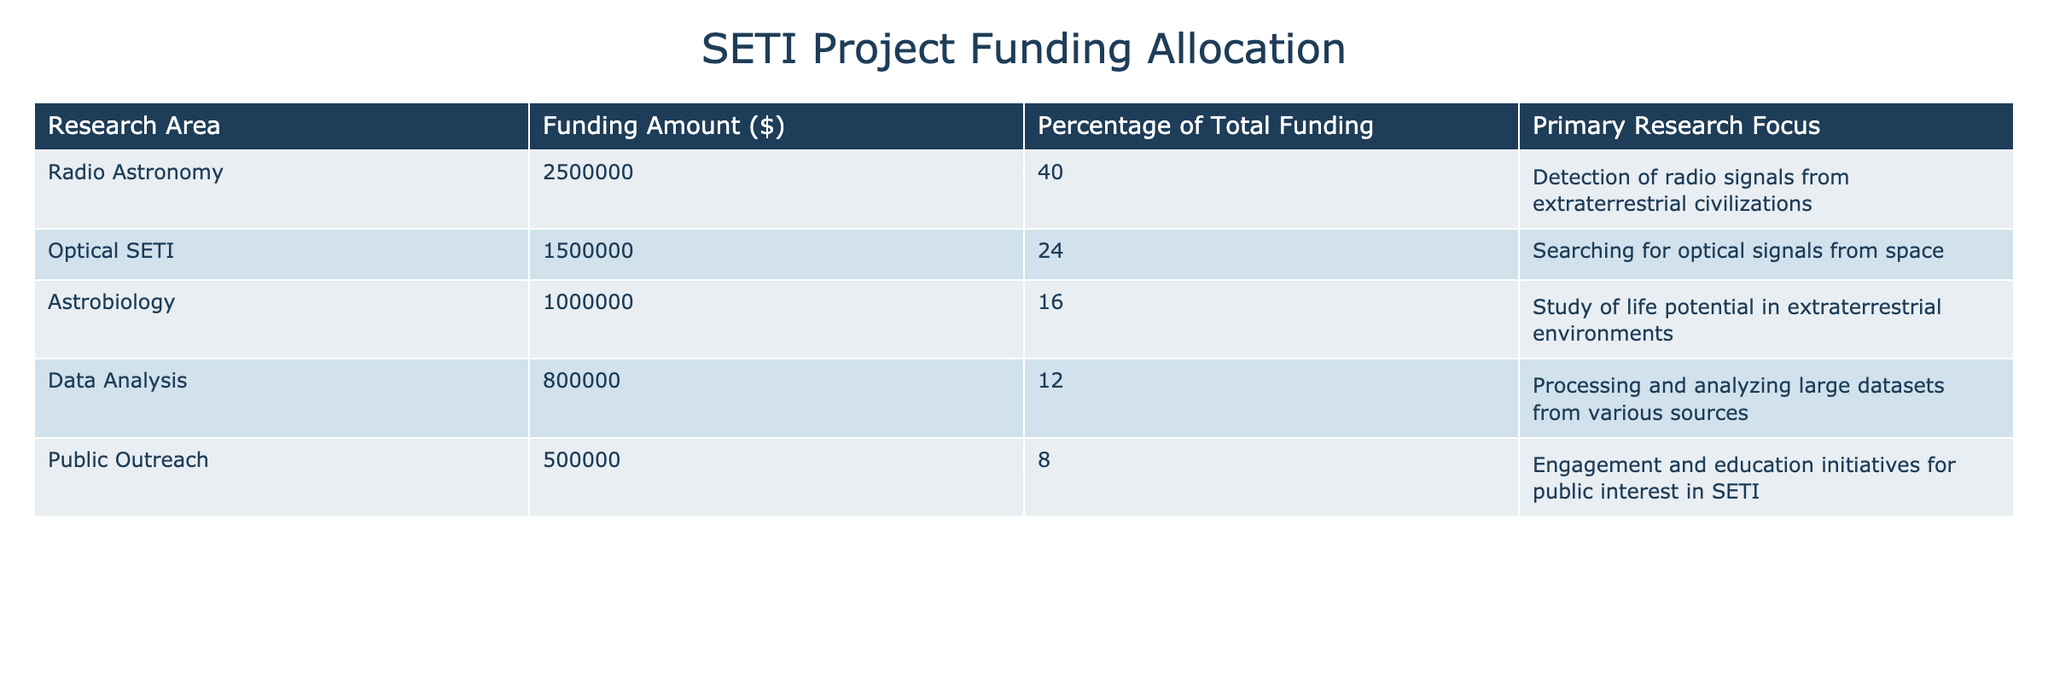What is the funding amount allocated to Radio Astronomy? The funding amount for Radio Astronomy is explicitly listed in the table under the "Funding Amount ($)" column. The value is 2,500,000 dollars.
Answer: 2,500,000 What percentage of total funding is allocated to Public Outreach? The percentage of total funding for Public Outreach is found in the "Percentage of Total Funding" column. The value indicated is 8%.
Answer: 8% Is the funding amount for Astrobiology greater than the funding amount for Data Analysis? To determine this, we compare the funding amounts in the table. Astrobiology has a funding amount of 1,000,000 dollars, while Data Analysis has 800,000 dollars. Since 1,000,000 is greater than 800,000, the statement is true.
Answer: Yes What is the total funding amount allocated to all research areas combined? We can find the total funding by summing all the amounts listed in the "Funding Amount ($)" column: 2,500,000 + 1,500,000 + 1,000,000 + 800,000 + 500,000 = 6,300,000 dollars.
Answer: 6,300,000 What is the average funding amount across all research areas? To find the average funding amount, we sum all the funding amounts (as calculated previously, 6,300,000) and divide by the number of research areas (which is 5). Thus, 6,300,000 / 5 = 1,260,000 dollars.
Answer: 1,260,000 Does the Optical SETI research area receive more funding than the combined total of Public Outreach and Data Analysis? First, we calculate the combined total for Public Outreach and Data Analysis, which is 500,000 + 800,000 = 1,300,000. Then we compare it with the funding for Optical SETI, which is 1,500,000. Since 1,500,000 is greater than 1,300,000, the answer is true.
Answer: Yes What is the funding amount for Data Analysis, and how does it compare to the funding amount for Astrobiology? The funding amount for Data Analysis is 800,000 dollars, while the funding amount for Astrobiology is 1,000,000 dollars. Comparing the two, 800,000 is less than 1,000,000, which shows that Data Analysis receives less funding.
Answer: Data Analysis receives less funding Which research area has the highest percentage of total funding and what is that percentage? The highest percentage of total funding can be found by looking for the maximum value in the "Percentage of Total Funding" column. Radio Astronomy has the highest at 40%.
Answer: Radio Astronomy, 40% 